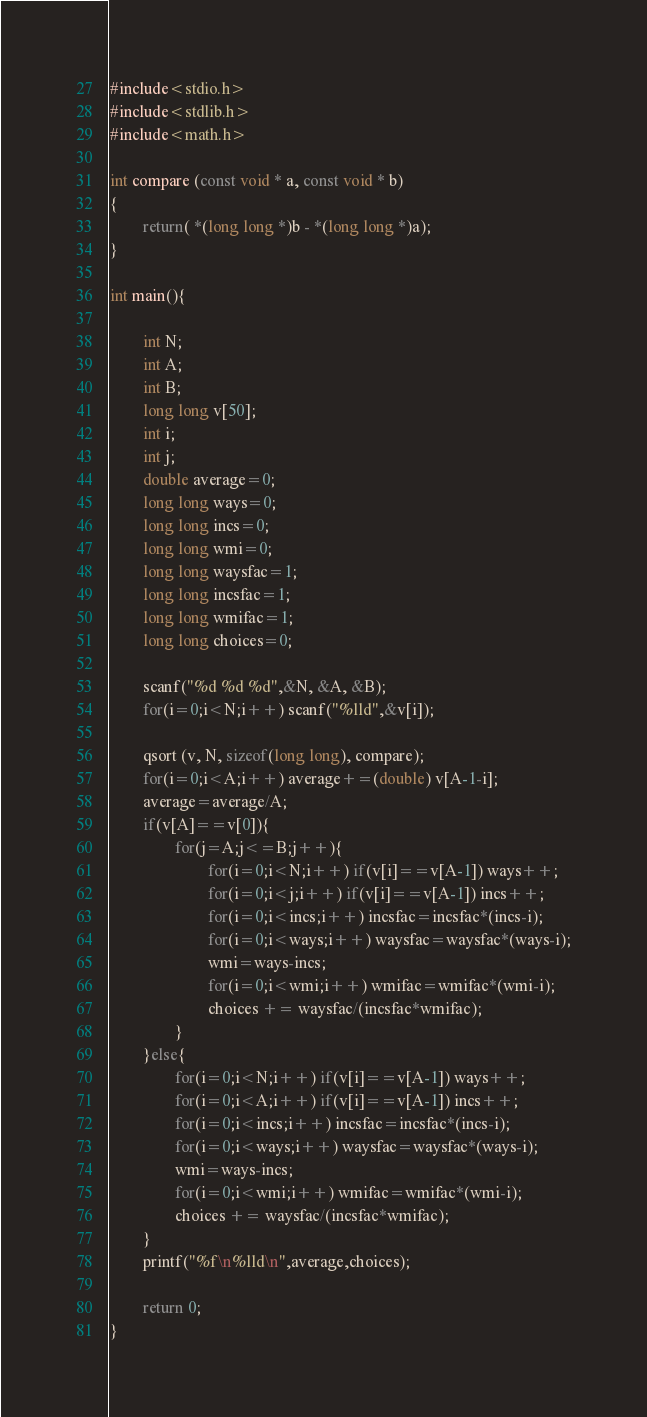<code> <loc_0><loc_0><loc_500><loc_500><_C_>#include<stdio.h>
#include<stdlib.h>
#include<math.h>

int compare (const void * a, const void * b)
{
        return( *(long long *)b - *(long long *)a);
}

int main(){

        int N;
        int A;
        int B;
        long long v[50];
        int i;
        int j;
        double average=0;
        long long ways=0;
        long long incs=0;
        long long wmi=0;
        long long waysfac=1;
        long long incsfac=1;
        long long wmifac=1;
        long long choices=0;

        scanf("%d %d %d",&N, &A, &B);
        for(i=0;i<N;i++) scanf("%lld",&v[i]);

        qsort (v, N, sizeof(long long), compare);
        for(i=0;i<A;i++) average+=(double) v[A-1-i];
        average=average/A;
        if(v[A]==v[0]){
                for(j=A;j<=B;j++){
                        for(i=0;i<N;i++) if(v[i]==v[A-1]) ways++;
                        for(i=0;i<j;i++) if(v[i]==v[A-1]) incs++;
                        for(i=0;i<incs;i++) incsfac=incsfac*(incs-i);
                        for(i=0;i<ways;i++) waysfac=waysfac*(ways-i);
                        wmi=ways-incs;
                        for(i=0;i<wmi;i++) wmifac=wmifac*(wmi-i);
                        choices += waysfac/(incsfac*wmifac);
                }
        }else{
                for(i=0;i<N;i++) if(v[i]==v[A-1]) ways++;
                for(i=0;i<A;i++) if(v[i]==v[A-1]) incs++;
                for(i=0;i<incs;i++) incsfac=incsfac*(incs-i);
                for(i=0;i<ways;i++) waysfac=waysfac*(ways-i);
                wmi=ways-incs;
                for(i=0;i<wmi;i++) wmifac=wmifac*(wmi-i);
                choices += waysfac/(incsfac*wmifac);
        }
        printf("%f\n%lld\n",average,choices);

        return 0;
}</code> 